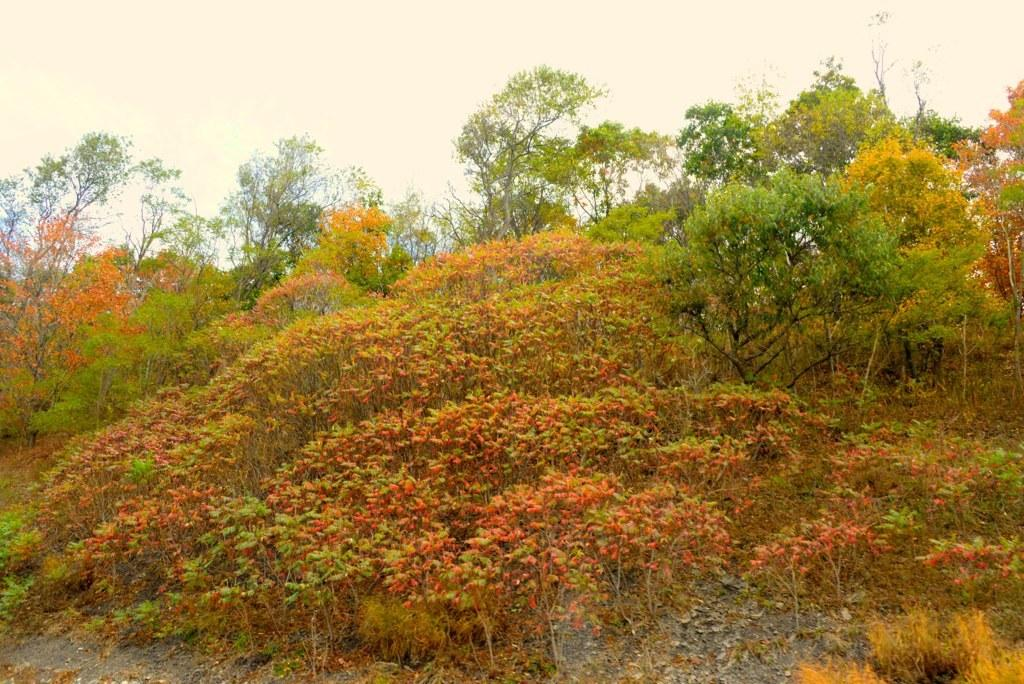What type of vegetation can be seen in the image? There are trees, plants, and grass in the image. Can you describe the leaves on a tree in the center of the image? The leaves on the tree in the center of the image are orange and green in color. What is visible at the top of the image? The sky is visible at the top of the image. How many cars are parked on the grass in the image? There are no cars present in the image; it features trees, plants, grass, and a tree with orange and green leaves. What time of day is it in the image, given the presence of the morning sun? The provided facts do not mention the time of day or the presence of the morning sun, so we cannot determine the time based on the image. 